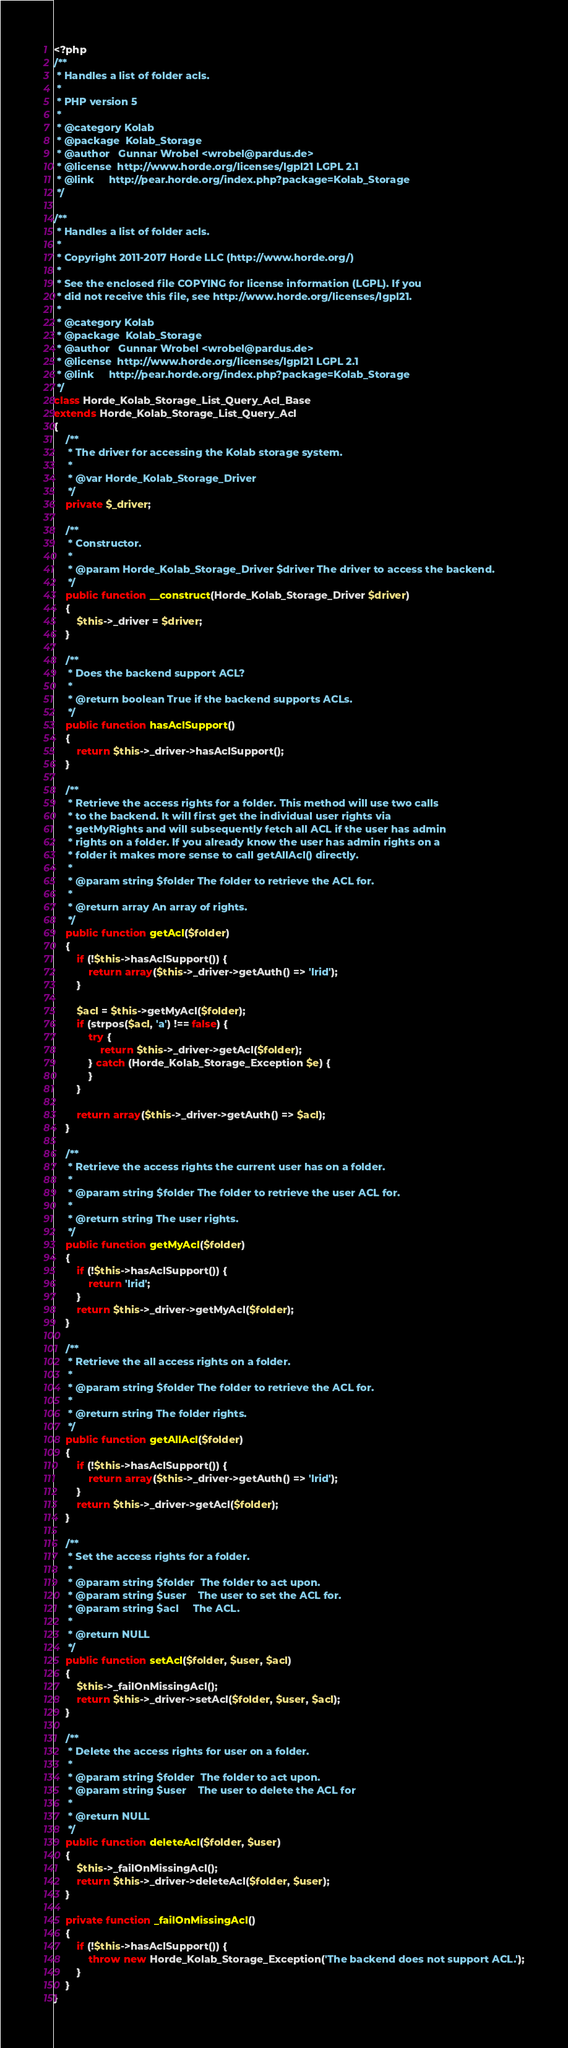<code> <loc_0><loc_0><loc_500><loc_500><_PHP_><?php
/**
 * Handles a list of folder acls.
 *
 * PHP version 5
 *
 * @category Kolab
 * @package  Kolab_Storage
 * @author   Gunnar Wrobel <wrobel@pardus.de>
 * @license  http://www.horde.org/licenses/lgpl21 LGPL 2.1
 * @link     http://pear.horde.org/index.php?package=Kolab_Storage
 */

/**
 * Handles a list of folder acls.
 *
 * Copyright 2011-2017 Horde LLC (http://www.horde.org/)
 *
 * See the enclosed file COPYING for license information (LGPL). If you
 * did not receive this file, see http://www.horde.org/licenses/lgpl21.
 *
 * @category Kolab
 * @package  Kolab_Storage
 * @author   Gunnar Wrobel <wrobel@pardus.de>
 * @license  http://www.horde.org/licenses/lgpl21 LGPL 2.1
 * @link     http://pear.horde.org/index.php?package=Kolab_Storage
 */
class Horde_Kolab_Storage_List_Query_Acl_Base
extends Horde_Kolab_Storage_List_Query_Acl
{
    /**
     * The driver for accessing the Kolab storage system.
     *
     * @var Horde_Kolab_Storage_Driver
     */
    private $_driver;

    /**
     * Constructor.
     *
     * @param Horde_Kolab_Storage_Driver $driver The driver to access the backend.
     */
    public function __construct(Horde_Kolab_Storage_Driver $driver)
    {
        $this->_driver = $driver;
    }

    /**
     * Does the backend support ACL?
     *
     * @return boolean True if the backend supports ACLs.
     */
    public function hasAclSupport()
    {
        return $this->_driver->hasAclSupport();
    }

    /**
     * Retrieve the access rights for a folder. This method will use two calls
     * to the backend. It will first get the individual user rights via
     * getMyRights and will subsequently fetch all ACL if the user has admin
     * rights on a folder. If you already know the user has admin rights on a
     * folder it makes more sense to call getAllAcl() directly.
     *
     * @param string $folder The folder to retrieve the ACL for.
     *
     * @return array An array of rights.
     */
    public function getAcl($folder)
    {
        if (!$this->hasAclSupport()) {
            return array($this->_driver->getAuth() => 'lrid');
        }

        $acl = $this->getMyAcl($folder);
        if (strpos($acl, 'a') !== false) {
            try {
                return $this->_driver->getAcl($folder);
            } catch (Horde_Kolab_Storage_Exception $e) {
            }
        }

        return array($this->_driver->getAuth() => $acl);
    }

    /**
     * Retrieve the access rights the current user has on a folder.
     *
     * @param string $folder The folder to retrieve the user ACL for.
     *
     * @return string The user rights.
     */
    public function getMyAcl($folder)
    {
        if (!$this->hasAclSupport()) {
            return 'lrid';
        }
        return $this->_driver->getMyAcl($folder);
    }

    /**
     * Retrieve the all access rights on a folder.
     *
     * @param string $folder The folder to retrieve the ACL for.
     *
     * @return string The folder rights.
     */
    public function getAllAcl($folder)
    {
        if (!$this->hasAclSupport()) {
            return array($this->_driver->getAuth() => 'lrid');
        }
        return $this->_driver->getAcl($folder);
    }

    /**
     * Set the access rights for a folder.
     *
     * @param string $folder  The folder to act upon.
     * @param string $user    The user to set the ACL for.
     * @param string $acl     The ACL.
     *
     * @return NULL
     */
    public function setAcl($folder, $user, $acl)
    {
        $this->_failOnMissingAcl();
        return $this->_driver->setAcl($folder, $user, $acl);
    }

    /**
     * Delete the access rights for user on a folder.
     *
     * @param string $folder  The folder to act upon.
     * @param string $user    The user to delete the ACL for
     *
     * @return NULL
     */
    public function deleteAcl($folder, $user)
    {
        $this->_failOnMissingAcl();
        return $this->_driver->deleteAcl($folder, $user);
    }

    private function _failOnMissingAcl()
    {
        if (!$this->hasAclSupport()) {
            throw new Horde_Kolab_Storage_Exception('The backend does not support ACL.');
        }
    }
}
</code> 